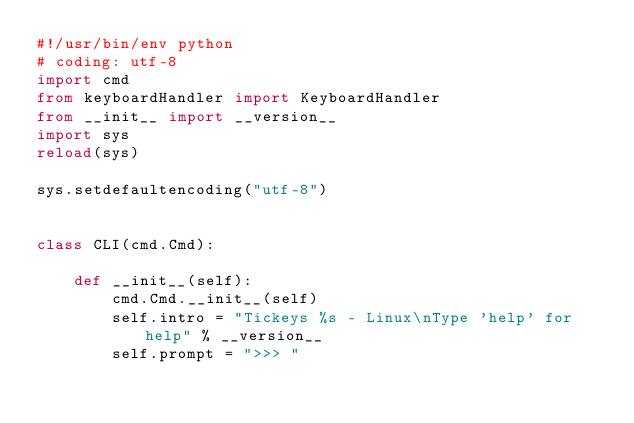<code> <loc_0><loc_0><loc_500><loc_500><_Python_>#!/usr/bin/env python
# coding: utf-8
import cmd
from keyboardHandler import KeyboardHandler
from __init__ import __version__
import sys
reload(sys)

sys.setdefaultencoding("utf-8")


class CLI(cmd.Cmd):

    def __init__(self):
        cmd.Cmd.__init__(self)
        self.intro = "Tickeys %s - Linux\nType 'help' for help" % __version__
        self.prompt = ">>> "</code> 